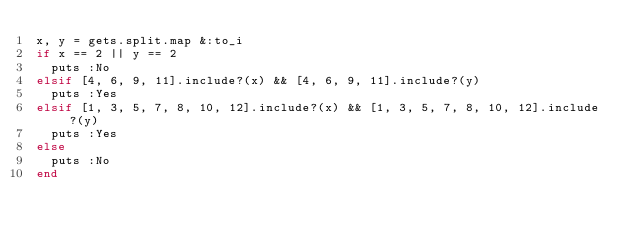Convert code to text. <code><loc_0><loc_0><loc_500><loc_500><_Ruby_>x, y = gets.split.map &:to_i
if x == 2 || y == 2
  puts :No
elsif [4, 6, 9, 11].include?(x) && [4, 6, 9, 11].include?(y)
  puts :Yes
elsif [1, 3, 5, 7, 8, 10, 12].include?(x) && [1, 3, 5, 7, 8, 10, 12].include?(y)
  puts :Yes
else
  puts :No
end</code> 